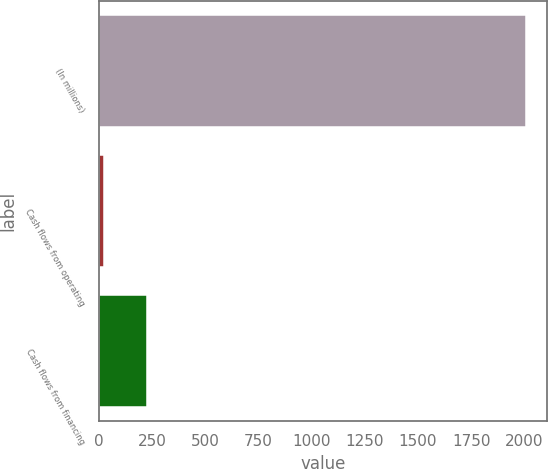<chart> <loc_0><loc_0><loc_500><loc_500><bar_chart><fcel>(In millions)<fcel>Cash flows from operating<fcel>Cash flows from financing<nl><fcel>2008<fcel>25<fcel>223.3<nl></chart> 